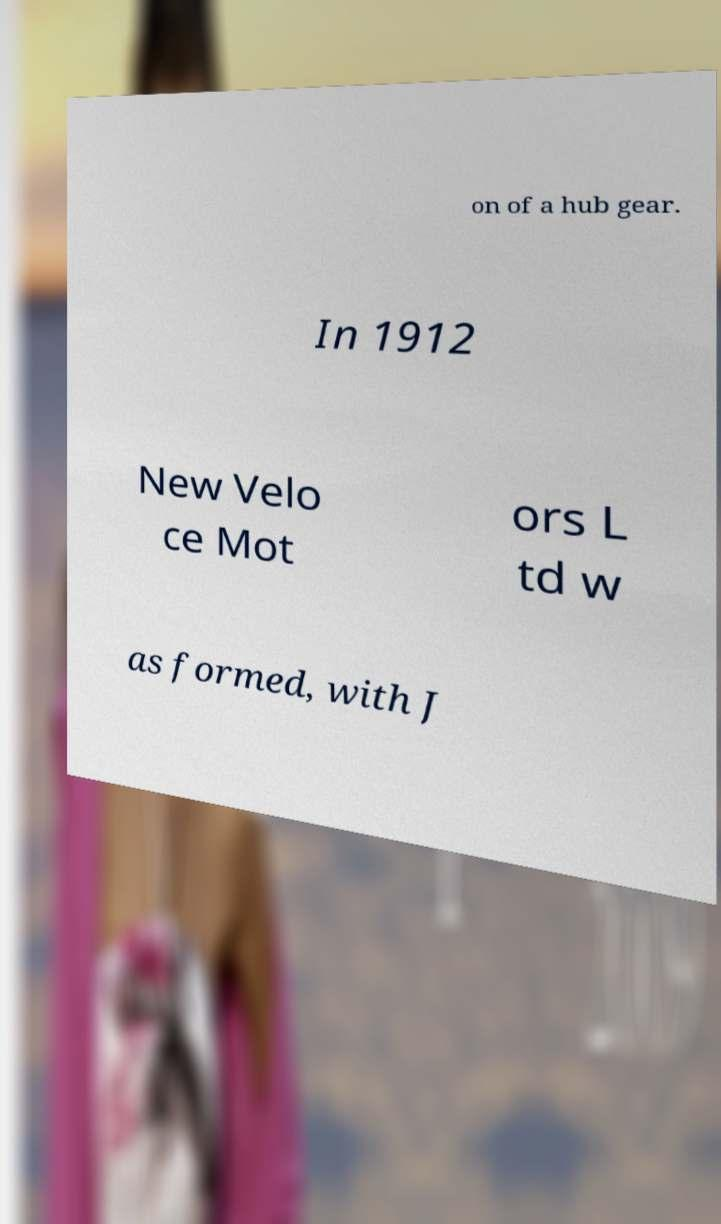What messages or text are displayed in this image? I need them in a readable, typed format. on of a hub gear. In 1912 New Velo ce Mot ors L td w as formed, with J 